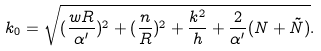<formula> <loc_0><loc_0><loc_500><loc_500>k _ { 0 } = \sqrt { ( \frac { w R } { \alpha ^ { \prime } } ) ^ { 2 } + ( \frac { n } { R } ) ^ { 2 } + \frac { k ^ { 2 } } { h } + \frac { 2 } { \alpha ^ { \prime } } ( N + \tilde { N } ) } .</formula> 